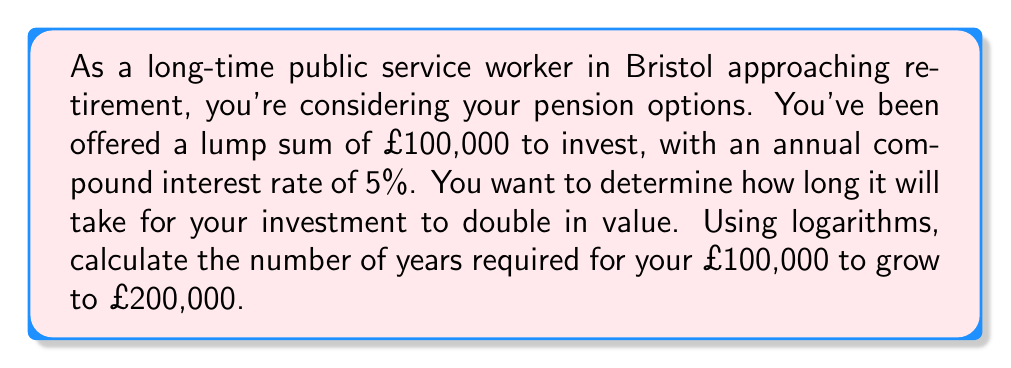Could you help me with this problem? To solve this problem, we'll use the compound interest formula and logarithms. Let's break it down step-by-step:

1) The compound interest formula is:
   $A = P(1 + r)^t$
   where:
   $A$ = final amount
   $P$ = principal (initial investment)
   $r$ = annual interest rate (as a decimal)
   $t$ = time in years

2) We know:
   $P = £100,000$
   $A = £200,000$ (double the initial amount)
   $r = 0.05$ (5% as a decimal)

3) Plugging these into the formula:
   $200,000 = 100,000(1 + 0.05)^t$

4) Simplify:
   $2 = (1.05)^t$

5) To solve for $t$, we need to use logarithms. Taking the natural log of both sides:
   $\ln(2) = \ln((1.05)^t)$

6) Using the logarithm property $\ln(a^b) = b\ln(a)$:
   $\ln(2) = t\ln(1.05)$

7) Solve for $t$:
   $t = \frac{\ln(2)}{\ln(1.05)}$

8) Calculate:
   $t = \frac{0.6931471806}{0.0487901142} \approx 14.2067$ years

Therefore, it will take approximately 14.21 years for the investment to double in value.
Answer: $t \approx 14.21$ years 